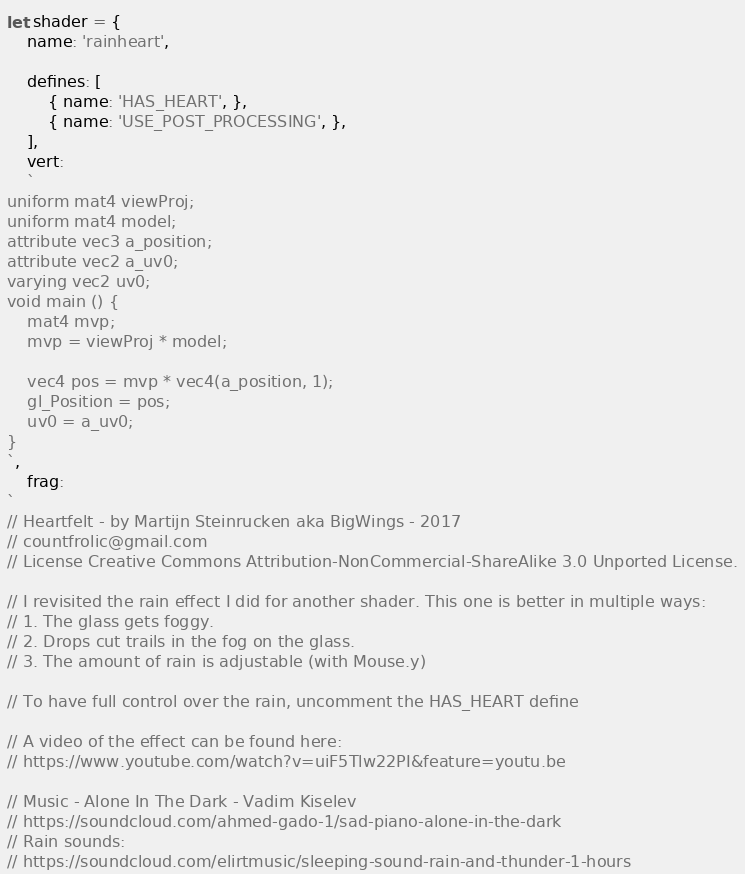Convert code to text. <code><loc_0><loc_0><loc_500><loc_500><_JavaScript_>let shader = {
    name: 'rainheart',

    defines: [
        { name: 'HAS_HEART', },
        { name: 'USE_POST_PROCESSING', },
    ],   
    vert: 
    `
uniform mat4 viewProj;
uniform mat4 model;
attribute vec3 a_position;
attribute vec2 a_uv0;
varying vec2 uv0;
void main () {
    mat4 mvp;
    mvp = viewProj * model;

    vec4 pos = mvp * vec4(a_position, 1);
    gl_Position = pos;
    uv0 = a_uv0;
}
`,
    frag:
`
// Heartfelt - by Martijn Steinrucken aka BigWings - 2017
// countfrolic@gmail.com
// License Creative Commons Attribution-NonCommercial-ShareAlike 3.0 Unported License.

// I revisited the rain effect I did for another shader. This one is better in multiple ways:
// 1. The glass gets foggy.
// 2. Drops cut trails in the fog on the glass.
// 3. The amount of rain is adjustable (with Mouse.y)

// To have full control over the rain, uncomment the HAS_HEART define 

// A video of the effect can be found here:
// https://www.youtube.com/watch?v=uiF5Tlw22PI&feature=youtu.be

// Music - Alone In The Dark - Vadim Kiselev
// https://soundcloud.com/ahmed-gado-1/sad-piano-alone-in-the-dark
// Rain sounds:
// https://soundcloud.com/elirtmusic/sleeping-sound-rain-and-thunder-1-hours
</code> 